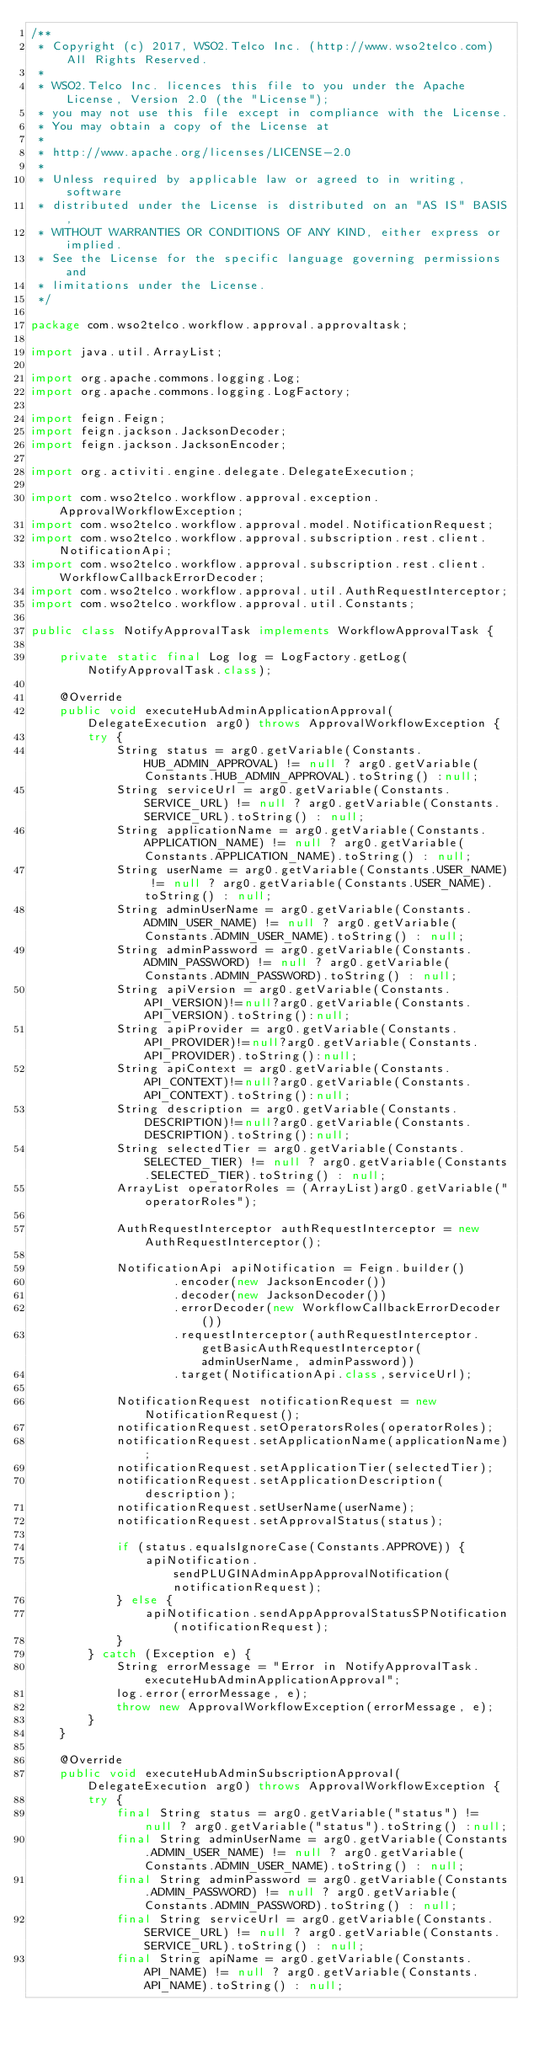Convert code to text. <code><loc_0><loc_0><loc_500><loc_500><_Java_>/**
 * Copyright (c) 2017, WSO2.Telco Inc. (http://www.wso2telco.com) All Rights Reserved.
 *
 * WSO2.Telco Inc. licences this file to you under the Apache License, Version 2.0 (the "License");
 * you may not use this file except in compliance with the License.
 * You may obtain a copy of the License at
 *
 * http://www.apache.org/licenses/LICENSE-2.0
 *
 * Unless required by applicable law or agreed to in writing, software
 * distributed under the License is distributed on an "AS IS" BASIS,
 * WITHOUT WARRANTIES OR CONDITIONS OF ANY KIND, either express or implied.
 * See the License for the specific language governing permissions and
 * limitations under the License.
 */

package com.wso2telco.workflow.approval.approvaltask;

import java.util.ArrayList;

import org.apache.commons.logging.Log;
import org.apache.commons.logging.LogFactory;

import feign.Feign;
import feign.jackson.JacksonDecoder;
import feign.jackson.JacksonEncoder;

import org.activiti.engine.delegate.DelegateExecution;

import com.wso2telco.workflow.approval.exception.ApprovalWorkflowException;
import com.wso2telco.workflow.approval.model.NotificationRequest;
import com.wso2telco.workflow.approval.subscription.rest.client.NotificationApi;
import com.wso2telco.workflow.approval.subscription.rest.client.WorkflowCallbackErrorDecoder;
import com.wso2telco.workflow.approval.util.AuthRequestInterceptor;
import com.wso2telco.workflow.approval.util.Constants;

public class NotifyApprovalTask implements WorkflowApprovalTask {

	private static final Log log = LogFactory.getLog(NotifyApprovalTask.class);

	@Override
	public void executeHubAdminApplicationApproval(DelegateExecution arg0) throws ApprovalWorkflowException {
		try {
			String status = arg0.getVariable(Constants.HUB_ADMIN_APPROVAL) != null ? arg0.getVariable(Constants.HUB_ADMIN_APPROVAL).toString() :null;
	        String serviceUrl = arg0.getVariable(Constants.SERVICE_URL) != null ? arg0.getVariable(Constants.SERVICE_URL).toString() : null;
	        String applicationName = arg0.getVariable(Constants.APPLICATION_NAME) != null ? arg0.getVariable(Constants.APPLICATION_NAME).toString() : null;
	        String userName = arg0.getVariable(Constants.USER_NAME) != null ? arg0.getVariable(Constants.USER_NAME).toString() : null;
	        String adminUserName = arg0.getVariable(Constants.ADMIN_USER_NAME) != null ? arg0.getVariable(Constants.ADMIN_USER_NAME).toString() : null;
	        String adminPassword = arg0.getVariable(Constants.ADMIN_PASSWORD) != null ? arg0.getVariable(Constants.ADMIN_PASSWORD).toString() : null;
	        String apiVersion = arg0.getVariable(Constants.API_VERSION)!=null?arg0.getVariable(Constants.API_VERSION).toString():null;
	        String apiProvider = arg0.getVariable(Constants.API_PROVIDER)!=null?arg0.getVariable(Constants.API_PROVIDER).toString():null;
	        String apiContext = arg0.getVariable(Constants.API_CONTEXT)!=null?arg0.getVariable(Constants.API_CONTEXT).toString():null;
	        String description = arg0.getVariable(Constants.DESCRIPTION)!=null?arg0.getVariable(Constants.DESCRIPTION).toString():null;
	        String selectedTier = arg0.getVariable(Constants.SELECTED_TIER) != null ? arg0.getVariable(Constants.SELECTED_TIER).toString() : null;
	        ArrayList operatorRoles = (ArrayList)arg0.getVariable("operatorRoles");

	        AuthRequestInterceptor authRequestInterceptor = new AuthRequestInterceptor();

	        NotificationApi apiNotification = Feign.builder()
	                .encoder(new JacksonEncoder())
	                .decoder(new JacksonDecoder())
	                .errorDecoder(new WorkflowCallbackErrorDecoder())
	                .requestInterceptor(authRequestInterceptor.getBasicAuthRequestInterceptor(adminUserName, adminPassword))
	                .target(NotificationApi.class,serviceUrl);

	        NotificationRequest notificationRequest = new NotificationRequest();
	        notificationRequest.setOperatorsRoles(operatorRoles);
	        notificationRequest.setApplicationName(applicationName);
	        notificationRequest.setApplicationTier(selectedTier);
	        notificationRequest.setApplicationDescription(description);
	        notificationRequest.setUserName(userName);
	        notificationRequest.setApprovalStatus(status);

	        if (status.equalsIgnoreCase(Constants.APPROVE)) {
	            apiNotification.sendPLUGINAdminAppApprovalNotification(notificationRequest);
	        } else {
	            apiNotification.sendAppApprovalStatusSPNotification(notificationRequest);
	        }
		} catch (Exception e) {
			String errorMessage = "Error in NotifyApprovalTask.executeHubAdminApplicationApproval";
			log.error(errorMessage, e);
			throw new ApprovalWorkflowException(errorMessage, e);
		}
	}

	@Override
	public void executeHubAdminSubscriptionApproval(DelegateExecution arg0) throws ApprovalWorkflowException {
		try {
			final String status = arg0.getVariable("status") != null ? arg0.getVariable("status").toString() :null;
	        final String adminUserName = arg0.getVariable(Constants.ADMIN_USER_NAME) != null ? arg0.getVariable(Constants.ADMIN_USER_NAME).toString() : null;
	        final String adminPassword = arg0.getVariable(Constants.ADMIN_PASSWORD) != null ? arg0.getVariable(Constants.ADMIN_PASSWORD).toString() : null;
	        final String serviceUrl = arg0.getVariable(Constants.SERVICE_URL) != null ? arg0.getVariable(Constants.SERVICE_URL).toString() : null;
	        final String apiName = arg0.getVariable(Constants.API_NAME) != null ? arg0.getVariable(Constants.API_NAME).toString() : null;</code> 